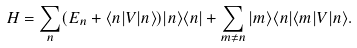Convert formula to latex. <formula><loc_0><loc_0><loc_500><loc_500>H = \sum _ { n } ( E _ { n } + \langle n | V | n \rangle ) | n \rangle \langle n | + \sum _ { m \neq n } | m \rangle \langle n | \langle m | V | n \rangle .</formula> 